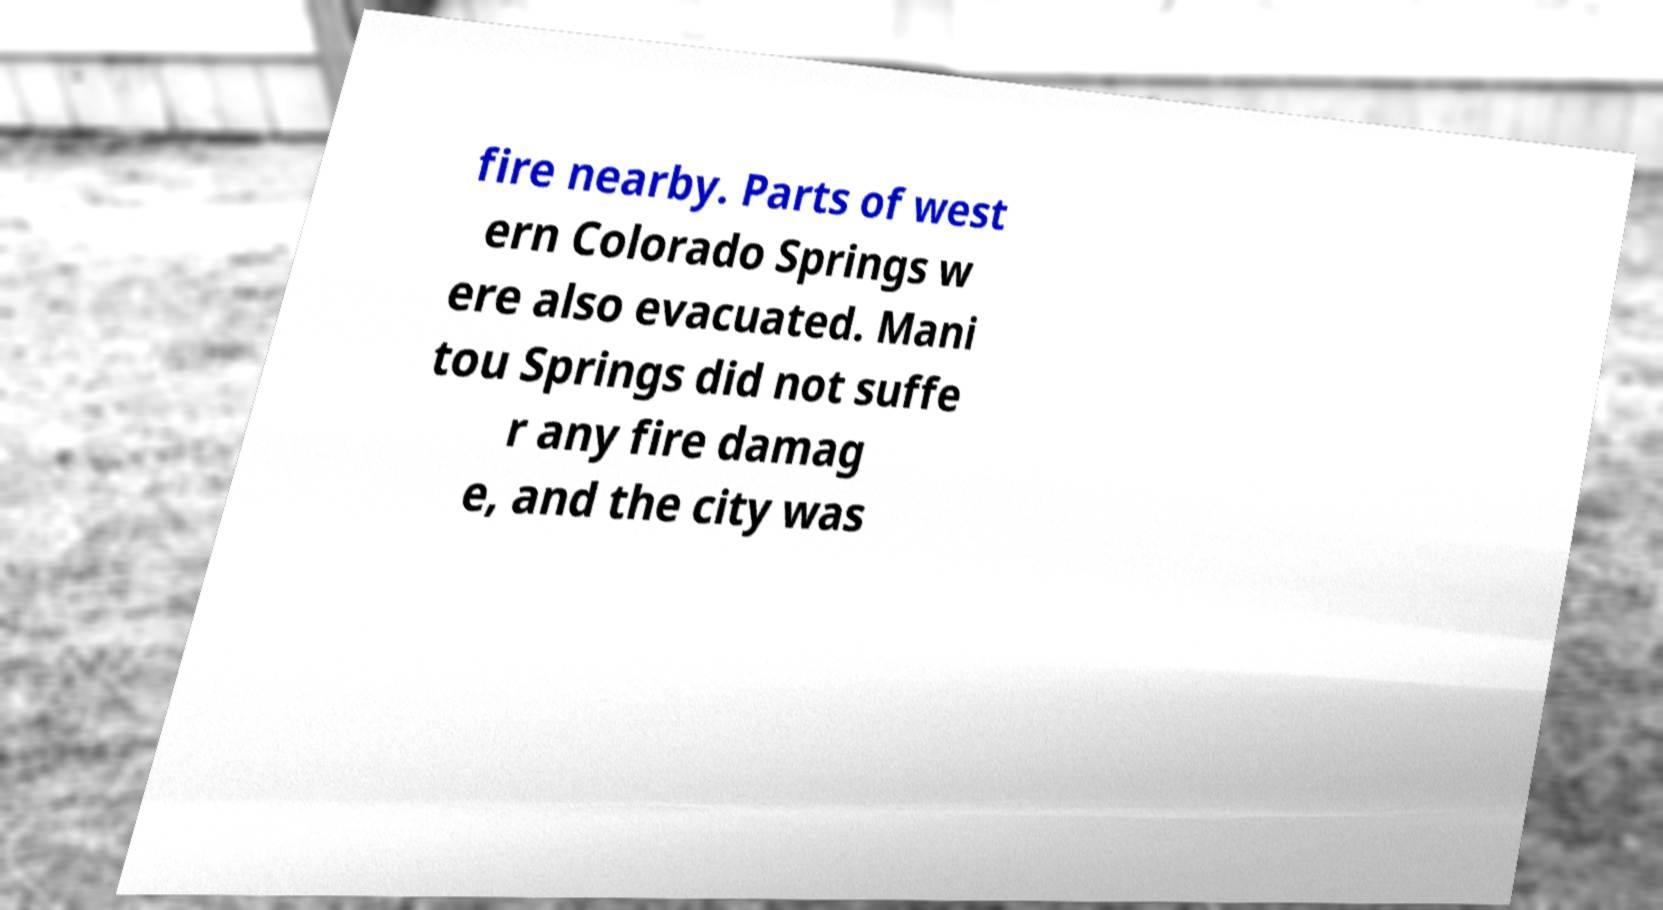Can you accurately transcribe the text from the provided image for me? fire nearby. Parts of west ern Colorado Springs w ere also evacuated. Mani tou Springs did not suffe r any fire damag e, and the city was 